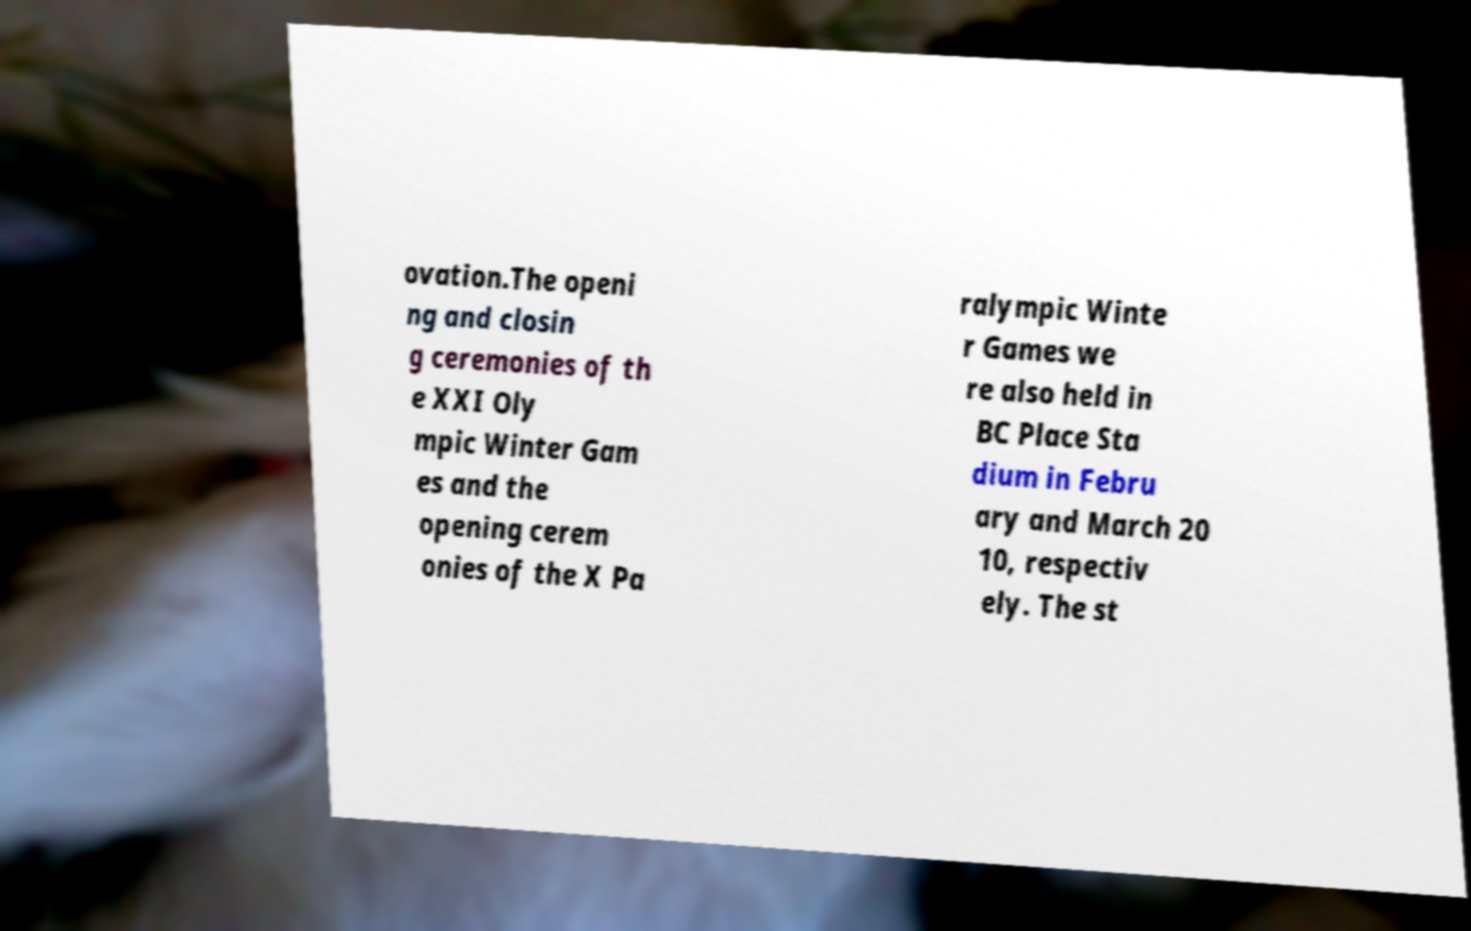There's text embedded in this image that I need extracted. Can you transcribe it verbatim? ovation.The openi ng and closin g ceremonies of th e XXI Oly mpic Winter Gam es and the opening cerem onies of the X Pa ralympic Winte r Games we re also held in BC Place Sta dium in Febru ary and March 20 10, respectiv ely. The st 